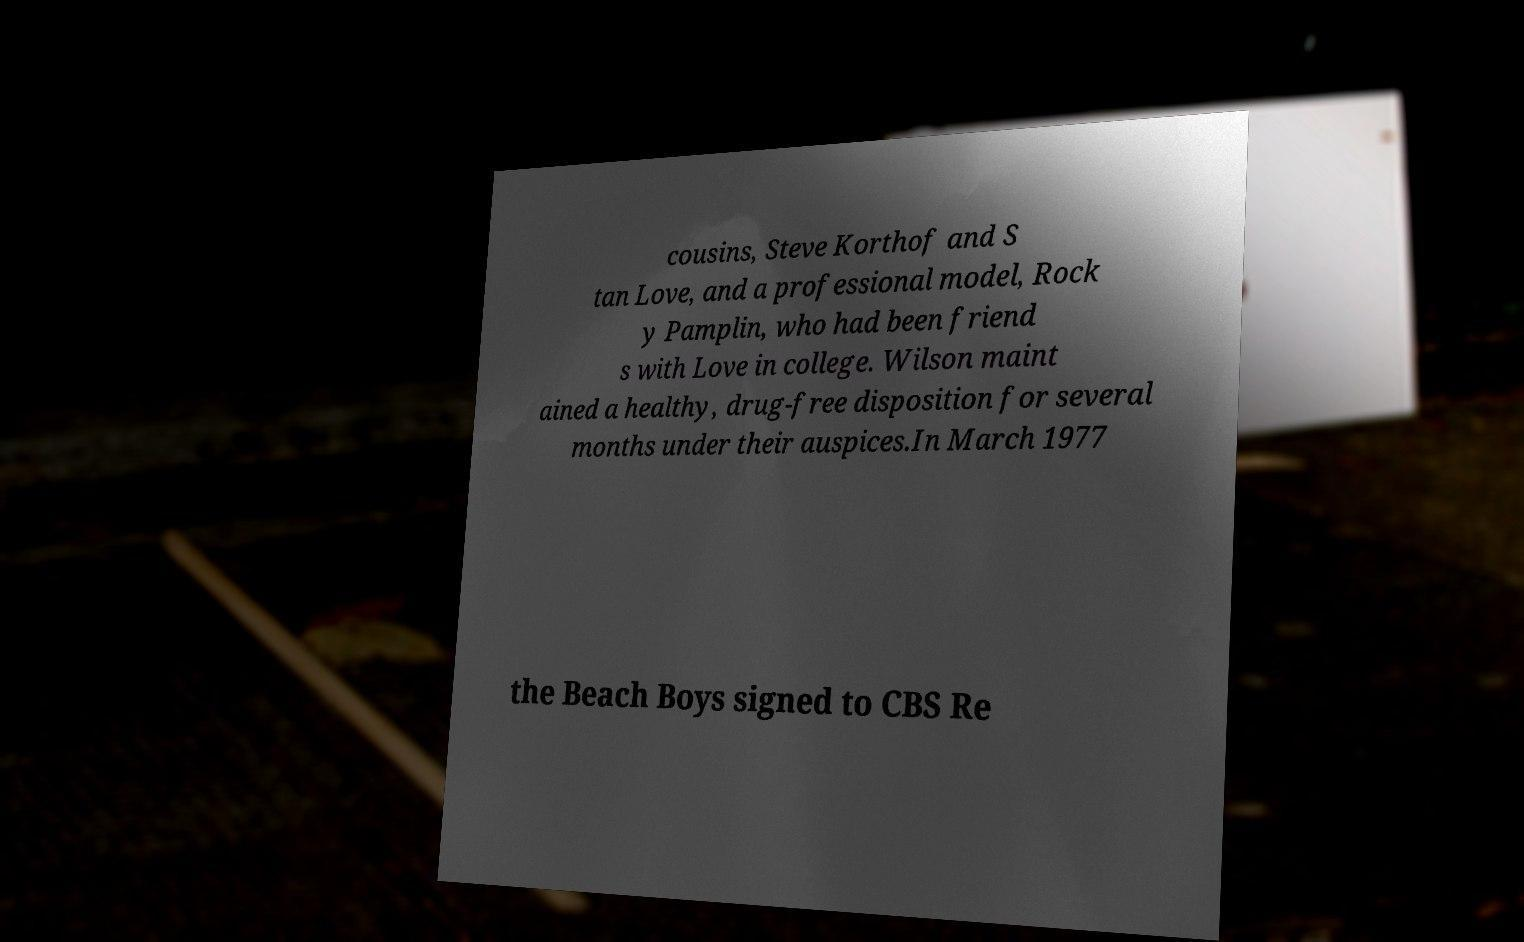Could you extract and type out the text from this image? cousins, Steve Korthof and S tan Love, and a professional model, Rock y Pamplin, who had been friend s with Love in college. Wilson maint ained a healthy, drug-free disposition for several months under their auspices.In March 1977 the Beach Boys signed to CBS Re 